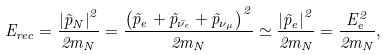<formula> <loc_0><loc_0><loc_500><loc_500>E _ { r e c } = \frac { \left | \vec { p } _ { N } \right | ^ { 2 } } { 2 m _ { N } } = \frac { \left ( \vec { p } _ { e } + \vec { p } _ { \bar { \nu } _ { e } } + \vec { p } _ { \nu _ { \mu } } \right ) ^ { 2 } } { 2 m _ { N } } \simeq \frac { \left | \vec { p } _ { e } \right | ^ { 2 } } { 2 m _ { N } } = \frac { E _ { e } ^ { 2 } } { 2 m _ { N } } ,</formula> 